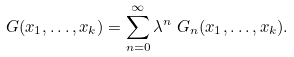Convert formula to latex. <formula><loc_0><loc_0><loc_500><loc_500>G ( x _ { 1 } , \dots , x _ { k } ) & = \sum _ { n = 0 } ^ { \infty } \lambda ^ { n } \ G _ { n } ( x _ { 1 } , \dots , x _ { k } ) .</formula> 